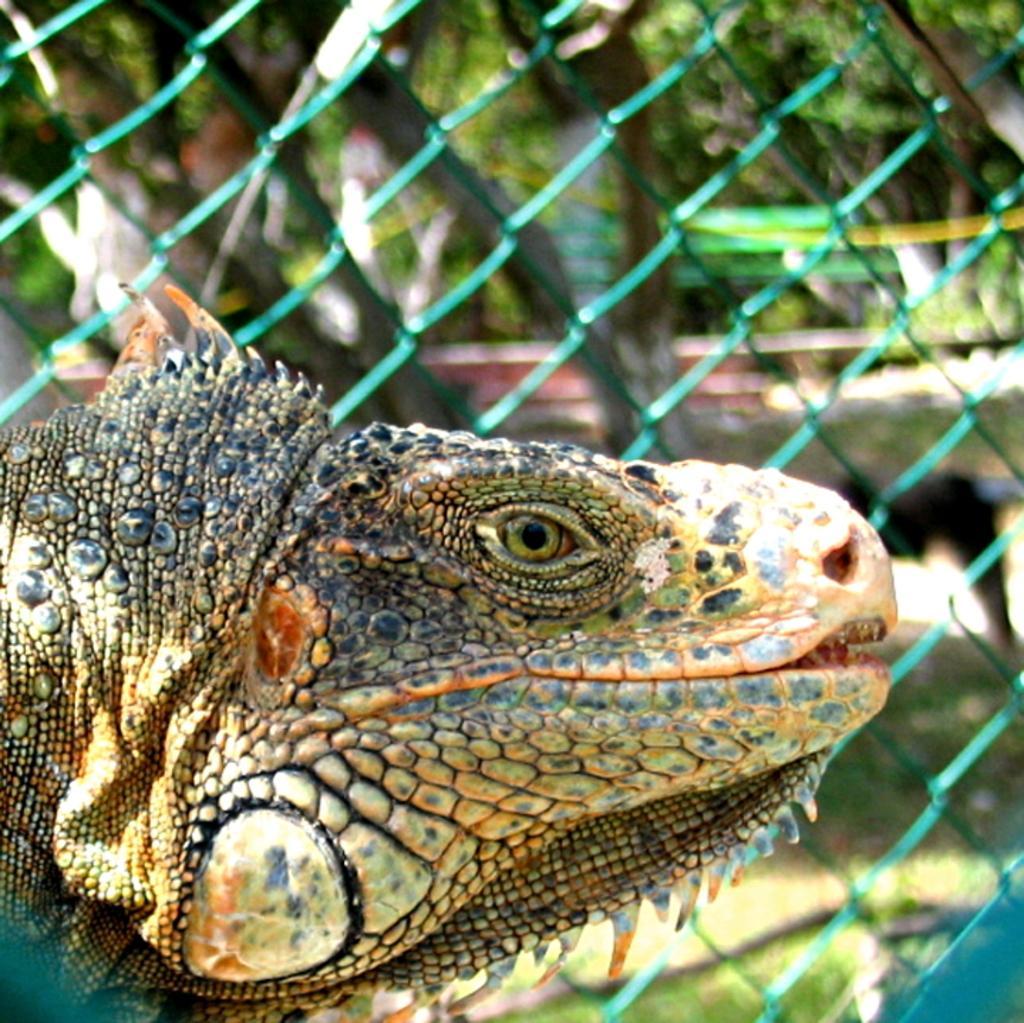In one or two sentences, can you explain what this image depicts? In this image, we can see a crocodile. In the background, we can see a net fence and trees. 